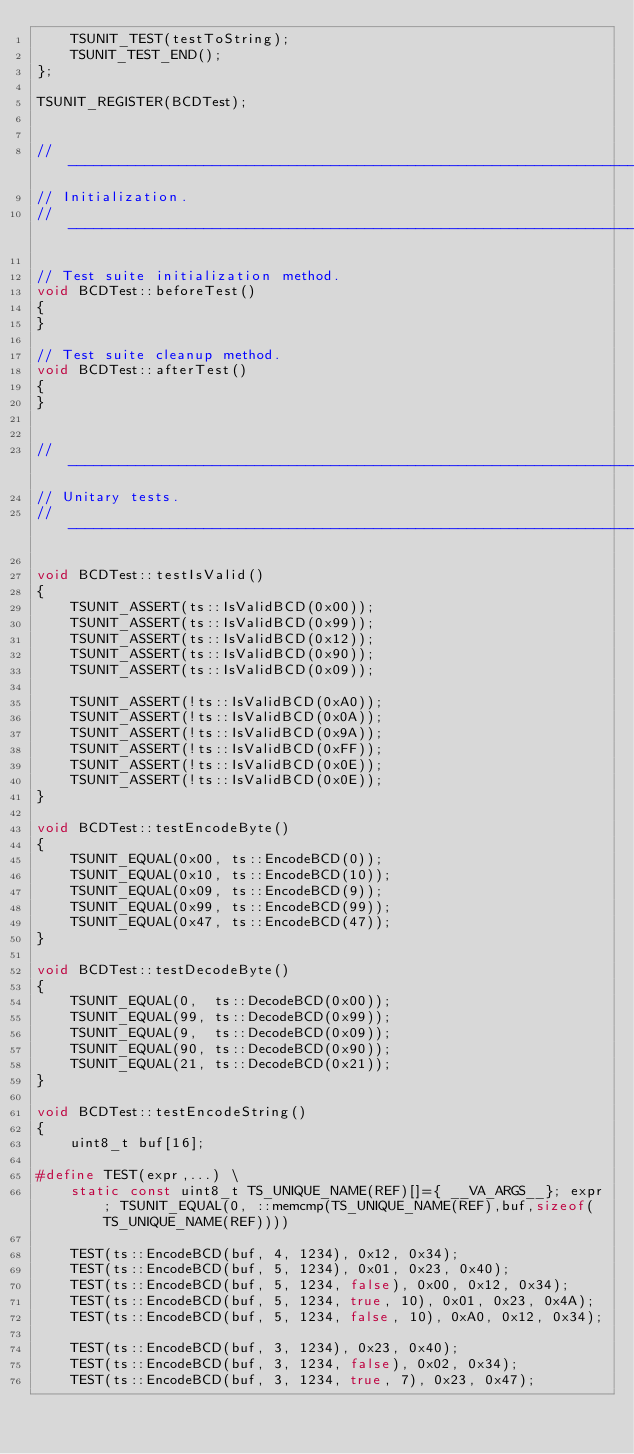Convert code to text. <code><loc_0><loc_0><loc_500><loc_500><_C++_>    TSUNIT_TEST(testToString);
    TSUNIT_TEST_END();
};

TSUNIT_REGISTER(BCDTest);


//----------------------------------------------------------------------------
// Initialization.
//----------------------------------------------------------------------------

// Test suite initialization method.
void BCDTest::beforeTest()
{
}

// Test suite cleanup method.
void BCDTest::afterTest()
{
}


//----------------------------------------------------------------------------
// Unitary tests.
//----------------------------------------------------------------------------

void BCDTest::testIsValid()
{
    TSUNIT_ASSERT(ts::IsValidBCD(0x00));
    TSUNIT_ASSERT(ts::IsValidBCD(0x99));
    TSUNIT_ASSERT(ts::IsValidBCD(0x12));
    TSUNIT_ASSERT(ts::IsValidBCD(0x90));
    TSUNIT_ASSERT(ts::IsValidBCD(0x09));

    TSUNIT_ASSERT(!ts::IsValidBCD(0xA0));
    TSUNIT_ASSERT(!ts::IsValidBCD(0x0A));
    TSUNIT_ASSERT(!ts::IsValidBCD(0x9A));
    TSUNIT_ASSERT(!ts::IsValidBCD(0xFF));
    TSUNIT_ASSERT(!ts::IsValidBCD(0x0E));
    TSUNIT_ASSERT(!ts::IsValidBCD(0x0E));
}

void BCDTest::testEncodeByte()
{
    TSUNIT_EQUAL(0x00, ts::EncodeBCD(0));
    TSUNIT_EQUAL(0x10, ts::EncodeBCD(10));
    TSUNIT_EQUAL(0x09, ts::EncodeBCD(9));
    TSUNIT_EQUAL(0x99, ts::EncodeBCD(99));
    TSUNIT_EQUAL(0x47, ts::EncodeBCD(47));
}

void BCDTest::testDecodeByte()
{
    TSUNIT_EQUAL(0,  ts::DecodeBCD(0x00));
    TSUNIT_EQUAL(99, ts::DecodeBCD(0x99));
    TSUNIT_EQUAL(9,  ts::DecodeBCD(0x09));
    TSUNIT_EQUAL(90, ts::DecodeBCD(0x90));
    TSUNIT_EQUAL(21, ts::DecodeBCD(0x21));
}

void BCDTest::testEncodeString()
{
    uint8_t buf[16];

#define TEST(expr,...) \
    static const uint8_t TS_UNIQUE_NAME(REF)[]={ __VA_ARGS__}; expr; TSUNIT_EQUAL(0, ::memcmp(TS_UNIQUE_NAME(REF),buf,sizeof(TS_UNIQUE_NAME(REF))))

    TEST(ts::EncodeBCD(buf, 4, 1234), 0x12, 0x34);
    TEST(ts::EncodeBCD(buf, 5, 1234), 0x01, 0x23, 0x40);
    TEST(ts::EncodeBCD(buf, 5, 1234, false), 0x00, 0x12, 0x34);
    TEST(ts::EncodeBCD(buf, 5, 1234, true, 10), 0x01, 0x23, 0x4A);
    TEST(ts::EncodeBCD(buf, 5, 1234, false, 10), 0xA0, 0x12, 0x34);

    TEST(ts::EncodeBCD(buf, 3, 1234), 0x23, 0x40);
    TEST(ts::EncodeBCD(buf, 3, 1234, false), 0x02, 0x34);
    TEST(ts::EncodeBCD(buf, 3, 1234, true, 7), 0x23, 0x47);</code> 